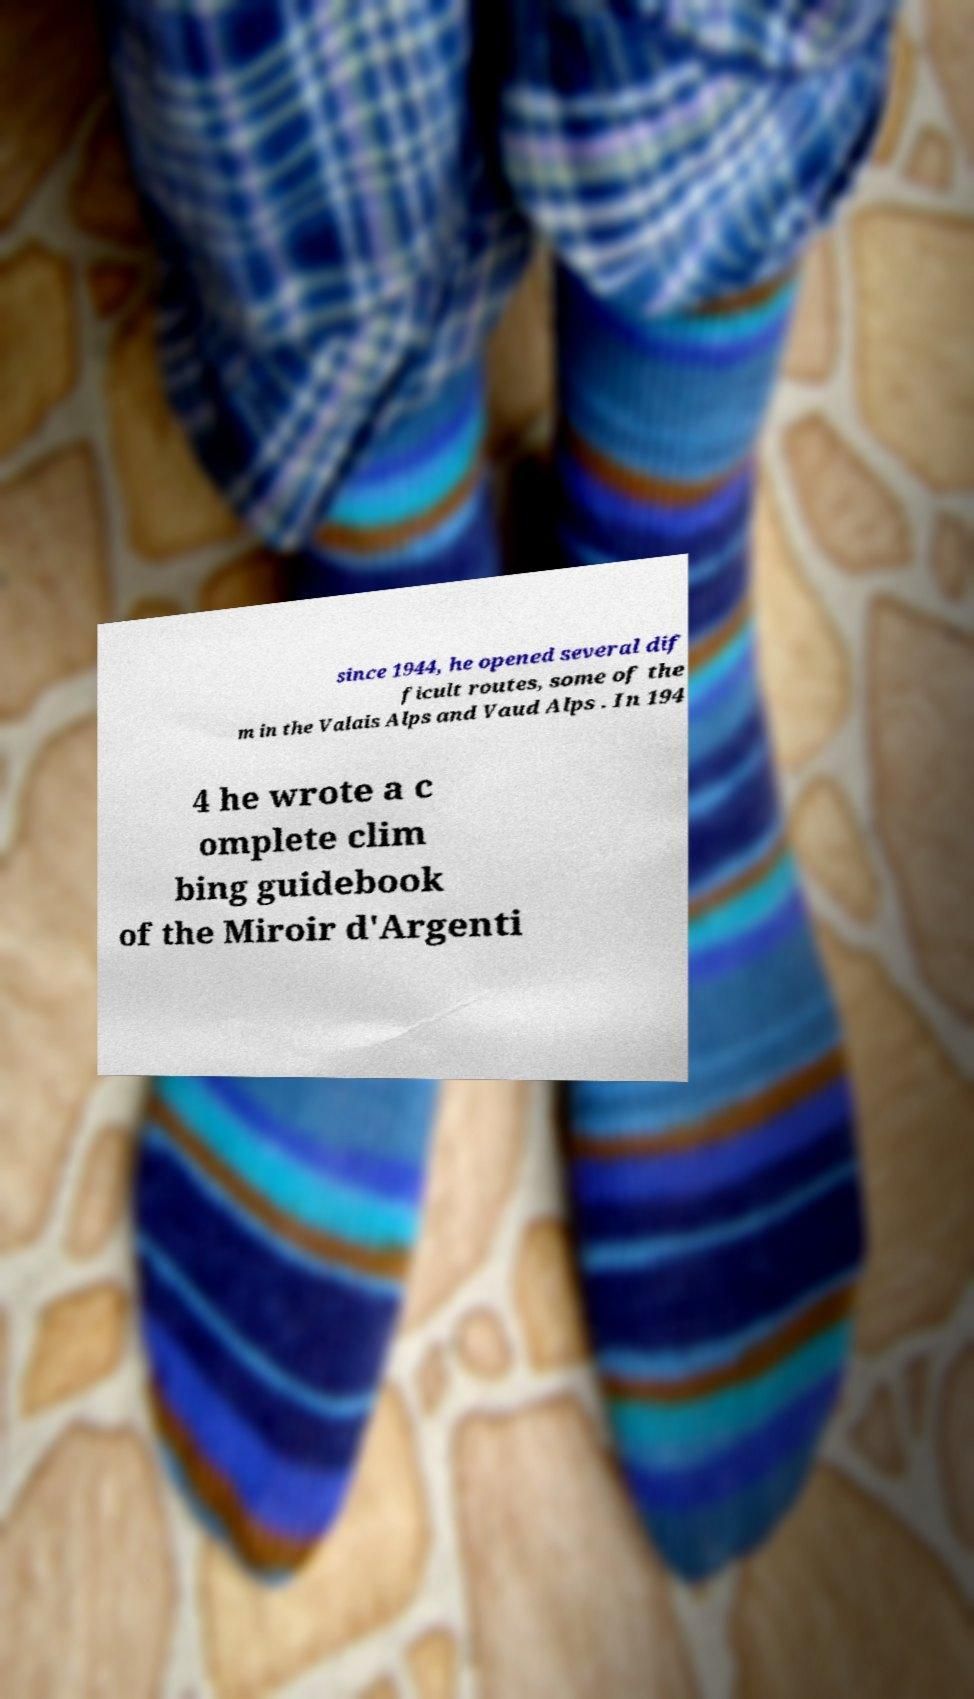Please read and relay the text visible in this image. What does it say? since 1944, he opened several dif ficult routes, some of the m in the Valais Alps and Vaud Alps . In 194 4 he wrote a c omplete clim bing guidebook of the Miroir d'Argenti 